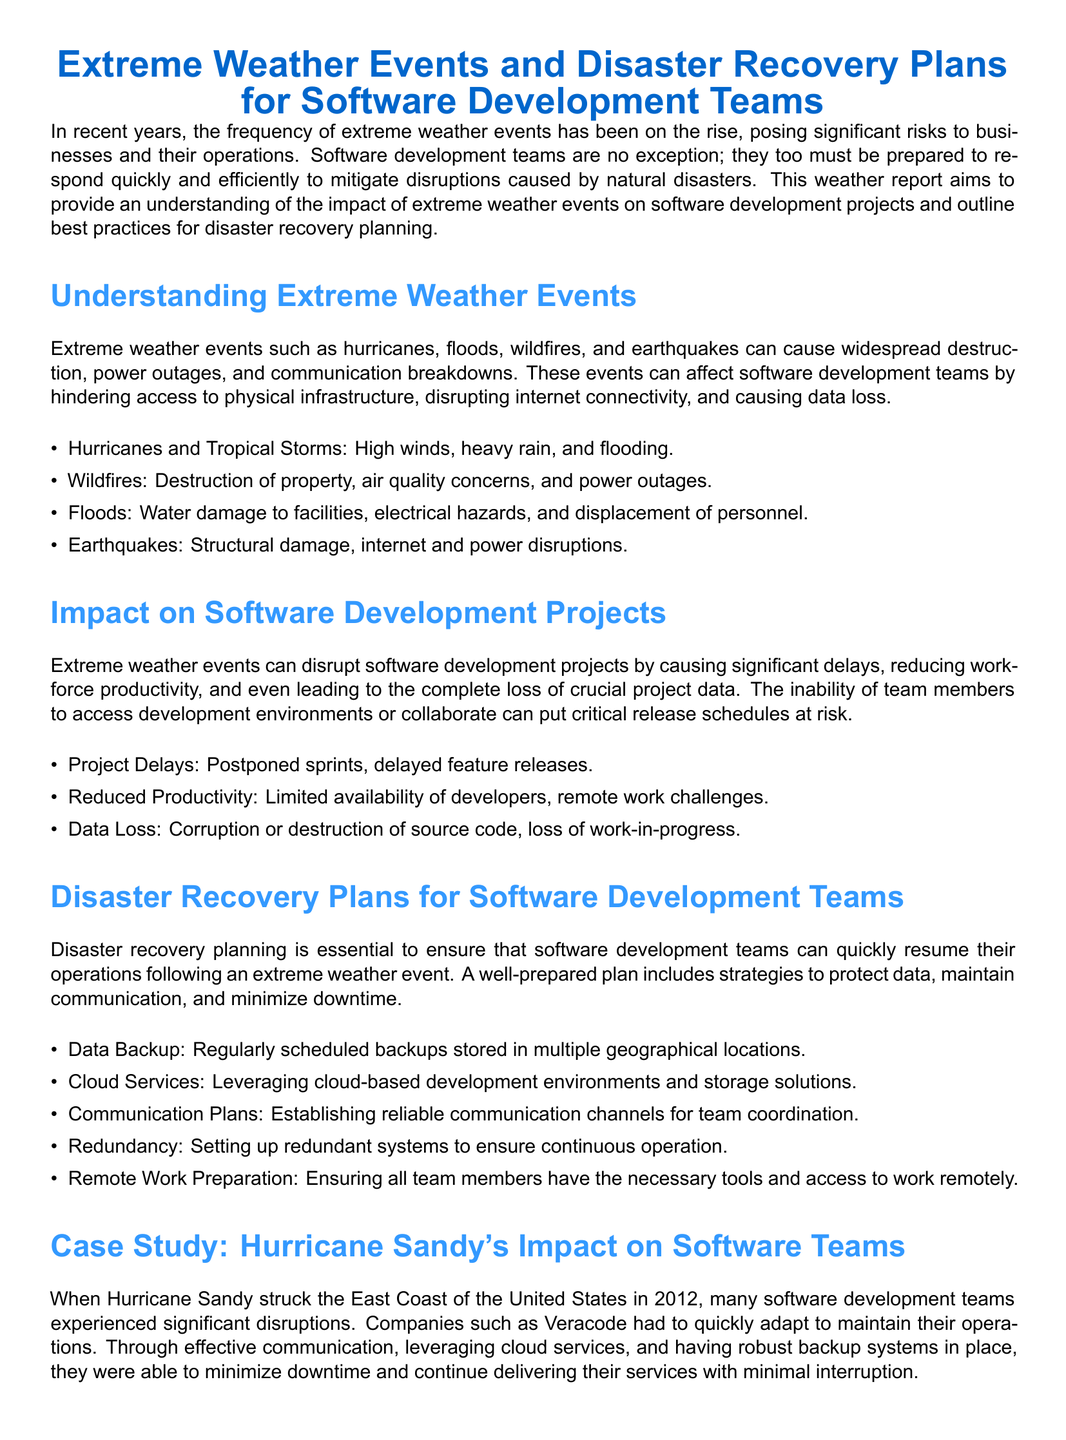What are some examples of extreme weather events? The document lists hurricanes, wildfires, floods, and earthquakes as examples of extreme weather events.
Answer: Hurricanes, wildfires, floods, earthquakes What is a primary impact of extreme weather events on software development? Extreme weather events can cause delays in project timelines.
Answer: Project Delays What should disaster recovery plans include for software development teams? The document states that regular backups in multiple locations are necessary for disaster recovery.
Answer: Data Backup Which hurricane impacted software teams in 2012? The document specifically mentions Hurricane Sandy as a significant event affecting software teams in 2012.
Answer: Hurricane Sandy What is one communication strategy recommended for disaster recovery planning? Establishing reliable communication channels for team coordination is recommended.
Answer: Communication Plans How can cloud services benefit software development during disasters? Leveraging cloud-based environments helps maintain operations during disruptions.
Answer: Cloud Services What year did Hurricane Sandy strike the East Coast? According to the document, Hurricane Sandy struck in 2012.
Answer: 2012 Why is it essential to have redundant systems? Redundant systems ensure continuous operation during failures or disasters.
Answer: Ensures continuous operation What aspect of disaster recovery plans should be regularly reviewed? The document emphasizes the importance of regularly reviewing and updating disaster recovery plans for effectiveness.
Answer: Regular review and updates 